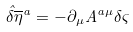<formula> <loc_0><loc_0><loc_500><loc_500>{ \hat { \delta } } { { \overline { \eta } } ^ { a } } = - \partial _ { \mu } A ^ { a \mu } \delta \varsigma</formula> 